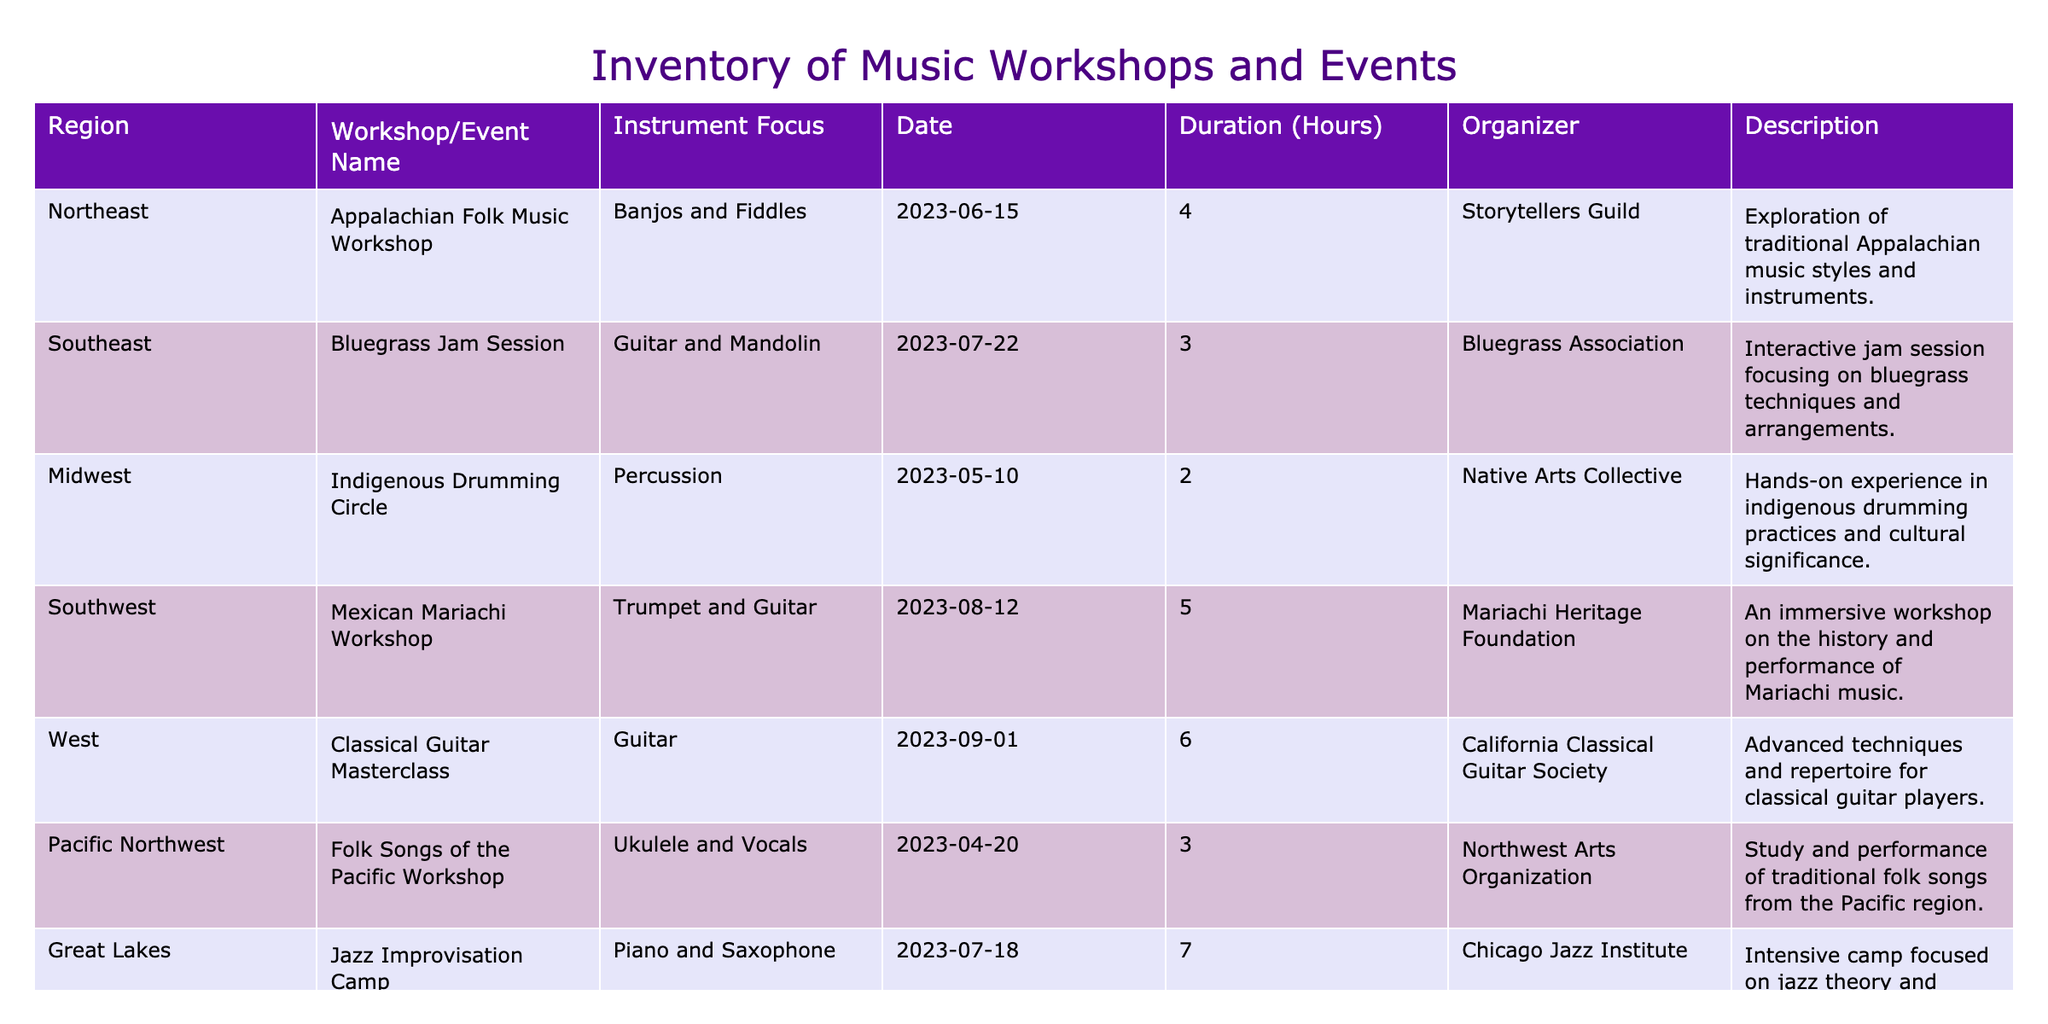What is the name of the workshop that focuses on traditional Appalachian music? The table indicates that the workshop focusing on traditional Appalachian music is called "Appalachian Folk Music Workshop". This can be found in the Northeast region row.
Answer: Appalachian Folk Music Workshop Which region hosted a workshop about Jazz improvisation? The table lists "Jazz Improvisation Camp" in the Great Lakes region, showing that this is where the workshop focused on jazz improvisation took place.
Answer: Great Lakes How many hours did the Mexican Mariachi Workshop last? The duration column of the "Mexican Mariachi Workshop" shows 5 hours. This data is directly retrievable from the corresponding row.
Answer: 5 Is there a workshop focused on percussion instruments? Yes, the "Indigenous Drumming Circle" focuses specifically on percussion instruments. This can be confirmed by looking at the Instrument Focus column.
Answer: Yes What is the total duration of music workshops in the Northeast region? From the table, only one workshop, the "Appalachian Folk Music Workshop," is listed in the Northeast region, which lasts 4 hours. Therefore, the total duration for this region is simply 4 hours.
Answer: 4 hours What type of music focuses on both guitar and mandolin, and in which region is it held? The "Bluegrass Jam Session," which focuses on guitar and mandolin, is held in the Southeast region. This is determined by examining the corresponding columns for the event name and region.
Answer: Southeast Which region has the longest workshop duration, and what is the duration? Looking through the duration column, the "Jazz Improvisation Camp" offers the longest duration of 7 hours, which is found in the Great Lakes region. Hence, the Great Lakes region has the longest workshop duration.
Answer: Great Lakes, 7 hours How many workshops were focused on folk instruments? Inspecting the table, there are two workshops that focus on folk instruments: "Appalachian Folk Music Workshop" and "Songwriting Retreat." Therefore, the total count of workshops dedicated to folk instruments is 2.
Answer: 2 Were any workshops organized by the "Native Arts Collective"? Yes, the "Indigenous Drumming Circle" is organized by the Native Arts Collective, as evidenced by the organizer column.
Answer: Yes 